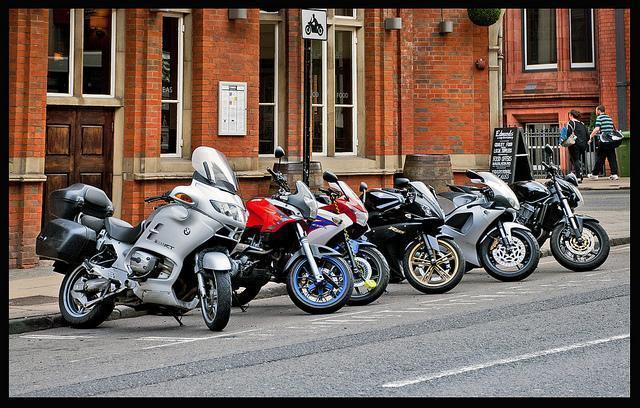What are bricks mostly made of?
Answer the question by selecting the correct answer among the 4 following choices and explain your choice with a short sentence. The answer should be formatted with the following format: `Answer: choice
Rationale: rationale.`
Options: Straw, sand, clay, pebbles. Answer: clay.
Rationale: Bricks are hard and molded into their shape, and clay is easily moldable and hardens when dried. 